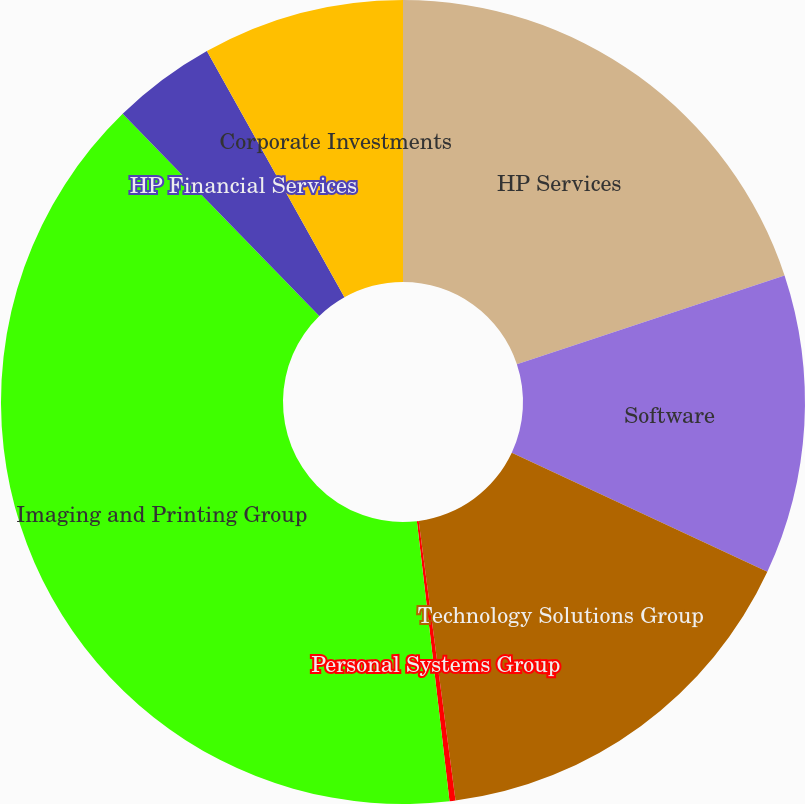Convert chart to OTSL. <chart><loc_0><loc_0><loc_500><loc_500><pie_chart><fcel>HP Services<fcel>Software<fcel>Technology Solutions Group<fcel>Personal Systems Group<fcel>Imaging and Printing Group<fcel>HP Financial Services<fcel>Corporate Investments<nl><fcel>19.9%<fcel>12.04%<fcel>15.97%<fcel>0.24%<fcel>39.56%<fcel>4.17%<fcel>8.11%<nl></chart> 